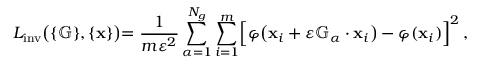<formula> <loc_0><loc_0><loc_500><loc_500>L _ { i n v } \left ( \{ \mathbb { G } \} , \{ \mathbf x \} \right ) = \frac { 1 } { m \varepsilon ^ { 2 } } \sum _ { \alpha = 1 } ^ { N _ { g } } \sum _ { i = 1 } ^ { m } \left [ \varphi \left ( x _ { i } + \varepsilon { \mathbb { G } _ { \alpha } } \cdot x _ { i } \right ) - \varphi ( x _ { i } ) \right ] ^ { 2 } \, ,</formula> 